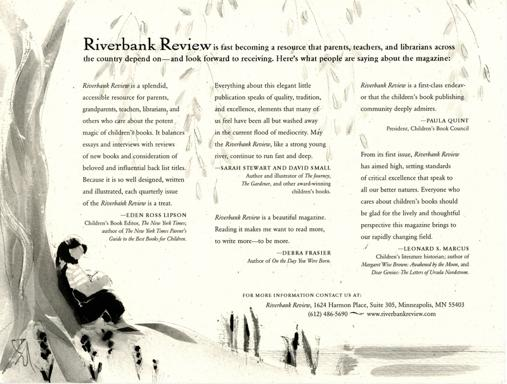What is the Riverbank Review about? The Riverbank Review is an esteemed publication dedicated to exploring the multifaceted world of children's literature. Insightfully composed, it offers literary criticisms, in-depth interviews with authors, and retrospectives that celebrate timeless literature for young readers. It stands out for its commitment to highlight the cultural and educational significance of children's stories and illustrations, such as those that might be reflected in the contemplative scene depicted in the provided image. 